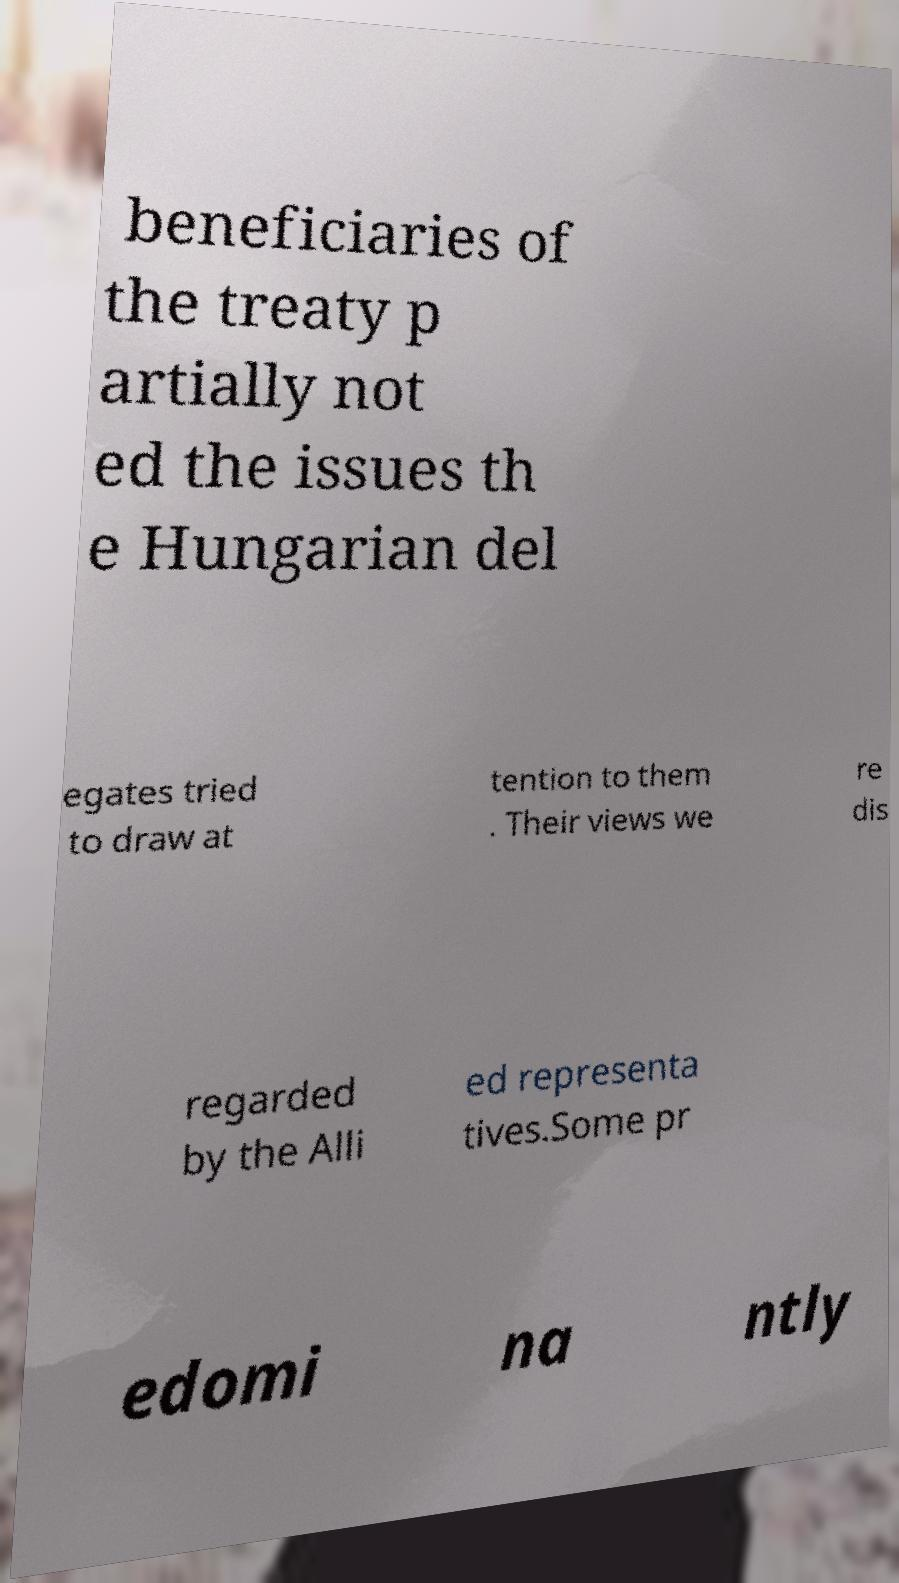I need the written content from this picture converted into text. Can you do that? beneficiaries of the treaty p artially not ed the issues th e Hungarian del egates tried to draw at tention to them . Their views we re dis regarded by the Alli ed representa tives.Some pr edomi na ntly 